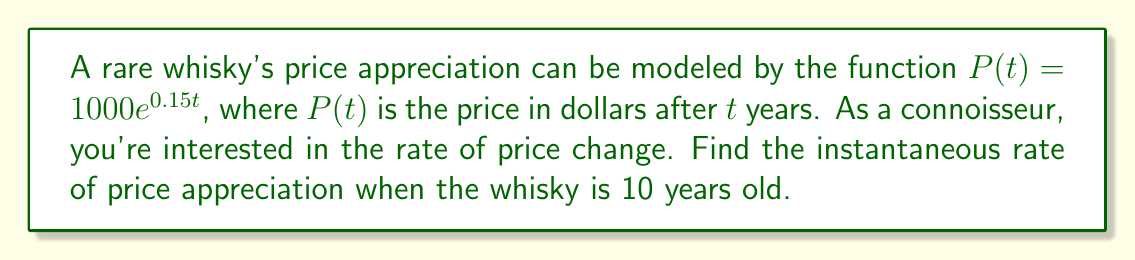Provide a solution to this math problem. To find the instantaneous rate of price appreciation at 10 years, we need to calculate the derivative of the price function $P(t)$ and evaluate it at $t=10$.

1) The given function is $P(t) = 1000e^{0.15t}$

2) To find the derivative, we use the chain rule:
   $$\frac{d}{dt}[P(t)] = 1000 \cdot \frac{d}{dt}[e^{0.15t}]$$
   $$P'(t) = 1000 \cdot 0.15e^{0.15t}$$
   $$P'(t) = 150e^{0.15t}$$

3) Now, we evaluate $P'(t)$ at $t=10$:
   $$P'(10) = 150e^{0.15 \cdot 10}$$
   $$P'(10) = 150e^{1.5}$$
   $$P'(10) = 150 \cdot 4.4817 \approx 672.25$$

4) The result, 672.25, represents the instantaneous rate of price appreciation in dollars per year when the whisky is 10 years old.
Answer: $672.25 per year 